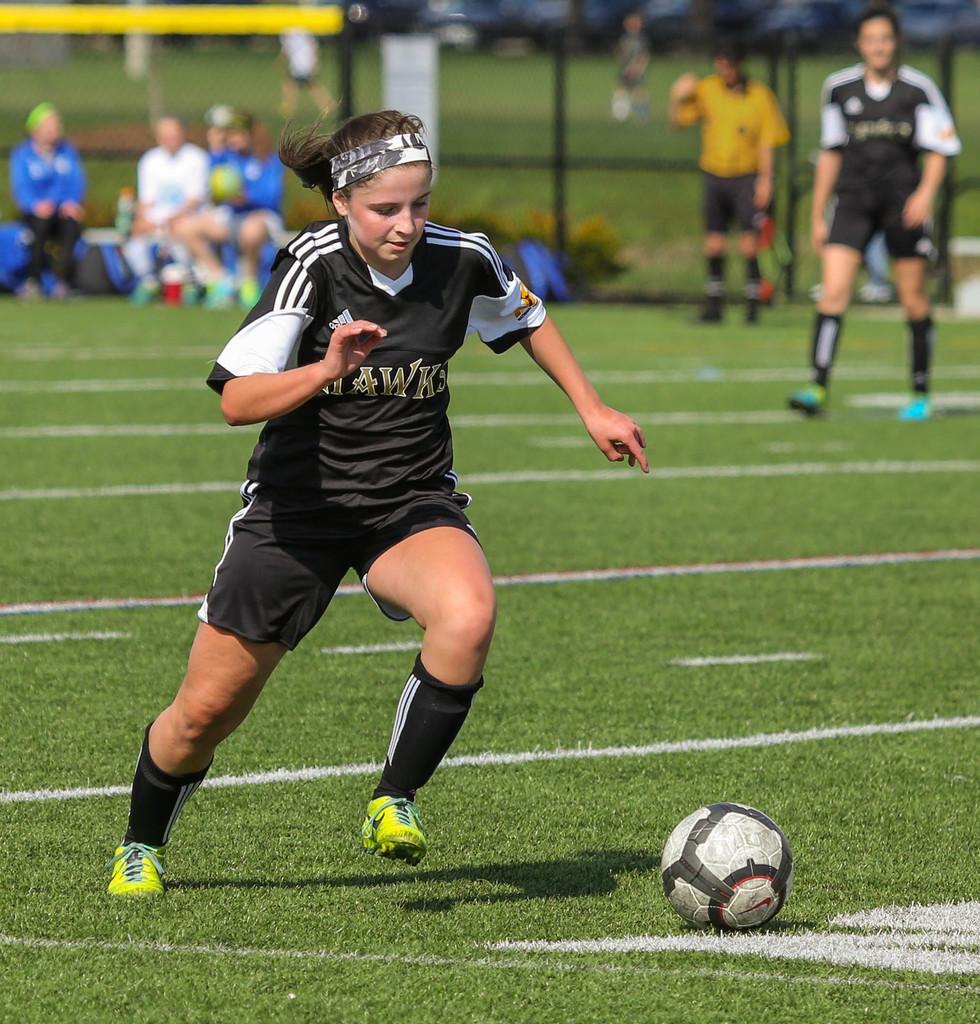In one or two sentences, can you explain what this image depicts? In the middle of the image a woman is running. Bottom right side of the image there is a football. Behind her there is grass. Top left side of the image few people are sitting on bench. Top right side of the image few people are standing. Behind them there is a fencing. 